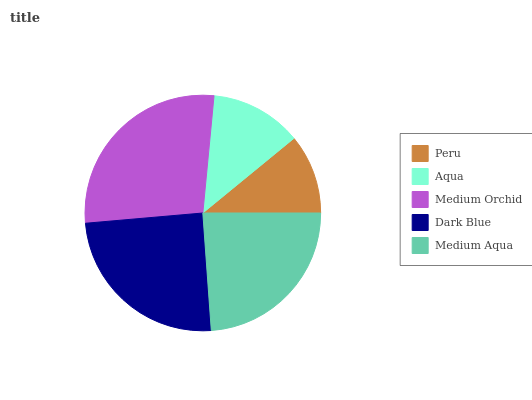Is Peru the minimum?
Answer yes or no. Yes. Is Medium Orchid the maximum?
Answer yes or no. Yes. Is Aqua the minimum?
Answer yes or no. No. Is Aqua the maximum?
Answer yes or no. No. Is Aqua greater than Peru?
Answer yes or no. Yes. Is Peru less than Aqua?
Answer yes or no. Yes. Is Peru greater than Aqua?
Answer yes or no. No. Is Aqua less than Peru?
Answer yes or no. No. Is Medium Aqua the high median?
Answer yes or no. Yes. Is Medium Aqua the low median?
Answer yes or no. Yes. Is Medium Orchid the high median?
Answer yes or no. No. Is Peru the low median?
Answer yes or no. No. 